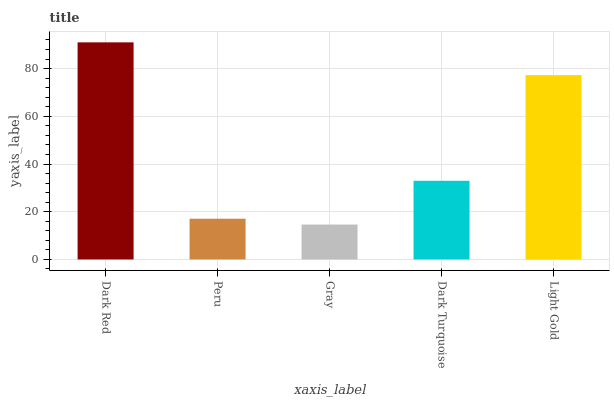Is Gray the minimum?
Answer yes or no. Yes. Is Dark Red the maximum?
Answer yes or no. Yes. Is Peru the minimum?
Answer yes or no. No. Is Peru the maximum?
Answer yes or no. No. Is Dark Red greater than Peru?
Answer yes or no. Yes. Is Peru less than Dark Red?
Answer yes or no. Yes. Is Peru greater than Dark Red?
Answer yes or no. No. Is Dark Red less than Peru?
Answer yes or no. No. Is Dark Turquoise the high median?
Answer yes or no. Yes. Is Dark Turquoise the low median?
Answer yes or no. Yes. Is Gray the high median?
Answer yes or no. No. Is Gray the low median?
Answer yes or no. No. 